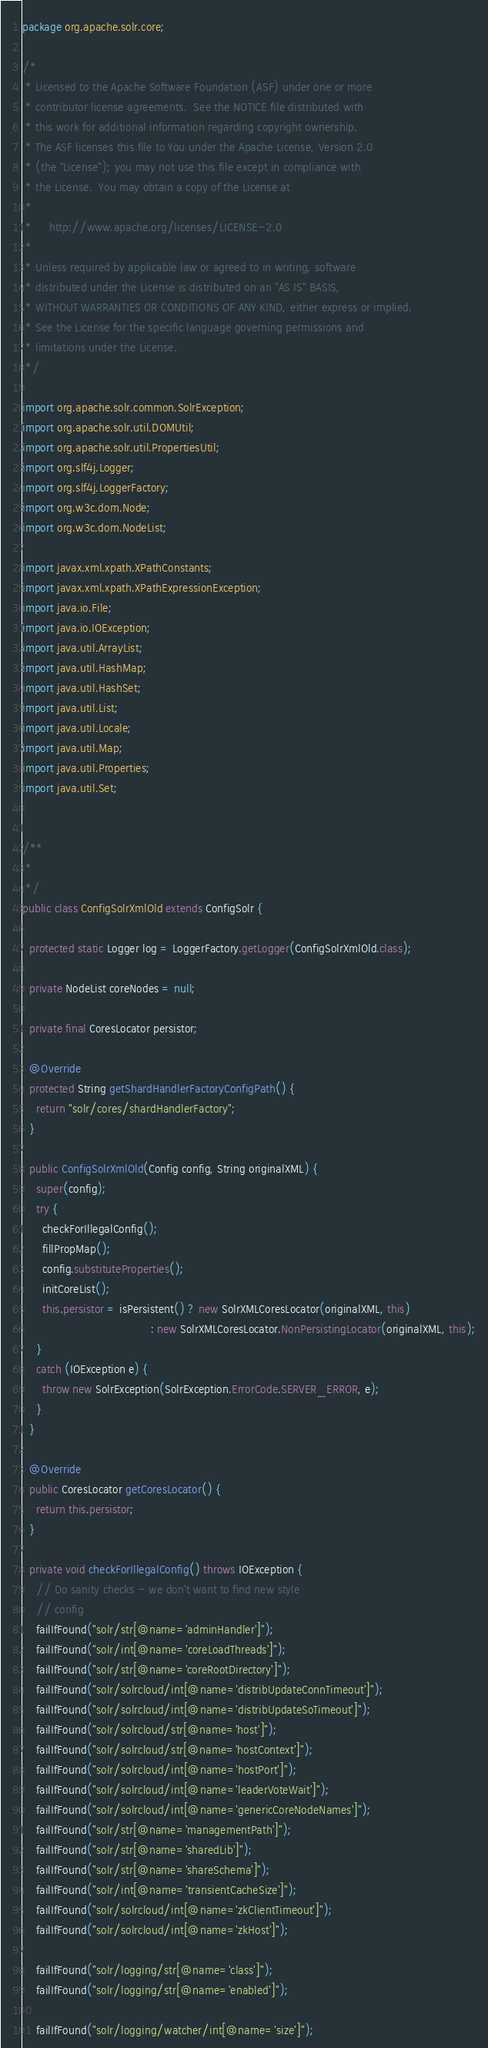Convert code to text. <code><loc_0><loc_0><loc_500><loc_500><_Java_>package org.apache.solr.core;

/*
 * Licensed to the Apache Software Foundation (ASF) under one or more
 * contributor license agreements.  See the NOTICE file distributed with
 * this work for additional information regarding copyright ownership.
 * The ASF licenses this file to You under the Apache License, Version 2.0
 * (the "License"); you may not use this file except in compliance with
 * the License.  You may obtain a copy of the License at
 *
 *     http://www.apache.org/licenses/LICENSE-2.0
 *
 * Unless required by applicable law or agreed to in writing, software
 * distributed under the License is distributed on an "AS IS" BASIS,
 * WITHOUT WARRANTIES OR CONDITIONS OF ANY KIND, either express or implied.
 * See the License for the specific language governing permissions and
 * limitations under the License.
 */

import org.apache.solr.common.SolrException;
import org.apache.solr.util.DOMUtil;
import org.apache.solr.util.PropertiesUtil;
import org.slf4j.Logger;
import org.slf4j.LoggerFactory;
import org.w3c.dom.Node;
import org.w3c.dom.NodeList;

import javax.xml.xpath.XPathConstants;
import javax.xml.xpath.XPathExpressionException;
import java.io.File;
import java.io.IOException;
import java.util.ArrayList;
import java.util.HashMap;
import java.util.HashSet;
import java.util.List;
import java.util.Locale;
import java.util.Map;
import java.util.Properties;
import java.util.Set;


/**
 *
 */
public class ConfigSolrXmlOld extends ConfigSolr {

  protected static Logger log = LoggerFactory.getLogger(ConfigSolrXmlOld.class);

  private NodeList coreNodes = null;
  
  private final CoresLocator persistor;

  @Override
  protected String getShardHandlerFactoryConfigPath() {
    return "solr/cores/shardHandlerFactory";
  }

  public ConfigSolrXmlOld(Config config, String originalXML) {
    super(config);
    try {
      checkForIllegalConfig();
      fillPropMap();
      config.substituteProperties();
      initCoreList();
      this.persistor = isPersistent() ? new SolrXMLCoresLocator(originalXML, this)
                                      : new SolrXMLCoresLocator.NonPersistingLocator(originalXML, this);
    }
    catch (IOException e) {
      throw new SolrException(SolrException.ErrorCode.SERVER_ERROR, e);
    }
  }

  @Override
  public CoresLocator getCoresLocator() {
    return this.persistor;
  }
  
  private void checkForIllegalConfig() throws IOException {
    // Do sanity checks - we don't want to find new style
    // config
    failIfFound("solr/str[@name='adminHandler']");
    failIfFound("solr/int[@name='coreLoadThreads']");
    failIfFound("solr/str[@name='coreRootDirectory']");
    failIfFound("solr/solrcloud/int[@name='distribUpdateConnTimeout']");
    failIfFound("solr/solrcloud/int[@name='distribUpdateSoTimeout']");
    failIfFound("solr/solrcloud/str[@name='host']");
    failIfFound("solr/solrcloud/str[@name='hostContext']");
    failIfFound("solr/solrcloud/int[@name='hostPort']");
    failIfFound("solr/solrcloud/int[@name='leaderVoteWait']");
    failIfFound("solr/solrcloud/int[@name='genericCoreNodeNames']");
    failIfFound("solr/str[@name='managementPath']");
    failIfFound("solr/str[@name='sharedLib']");
    failIfFound("solr/str[@name='shareSchema']");
    failIfFound("solr/int[@name='transientCacheSize']");
    failIfFound("solr/solrcloud/int[@name='zkClientTimeout']");
    failIfFound("solr/solrcloud/int[@name='zkHost']");
    
    failIfFound("solr/logging/str[@name='class']");
    failIfFound("solr/logging/str[@name='enabled']");
    
    failIfFound("solr/logging/watcher/int[@name='size']");</code> 